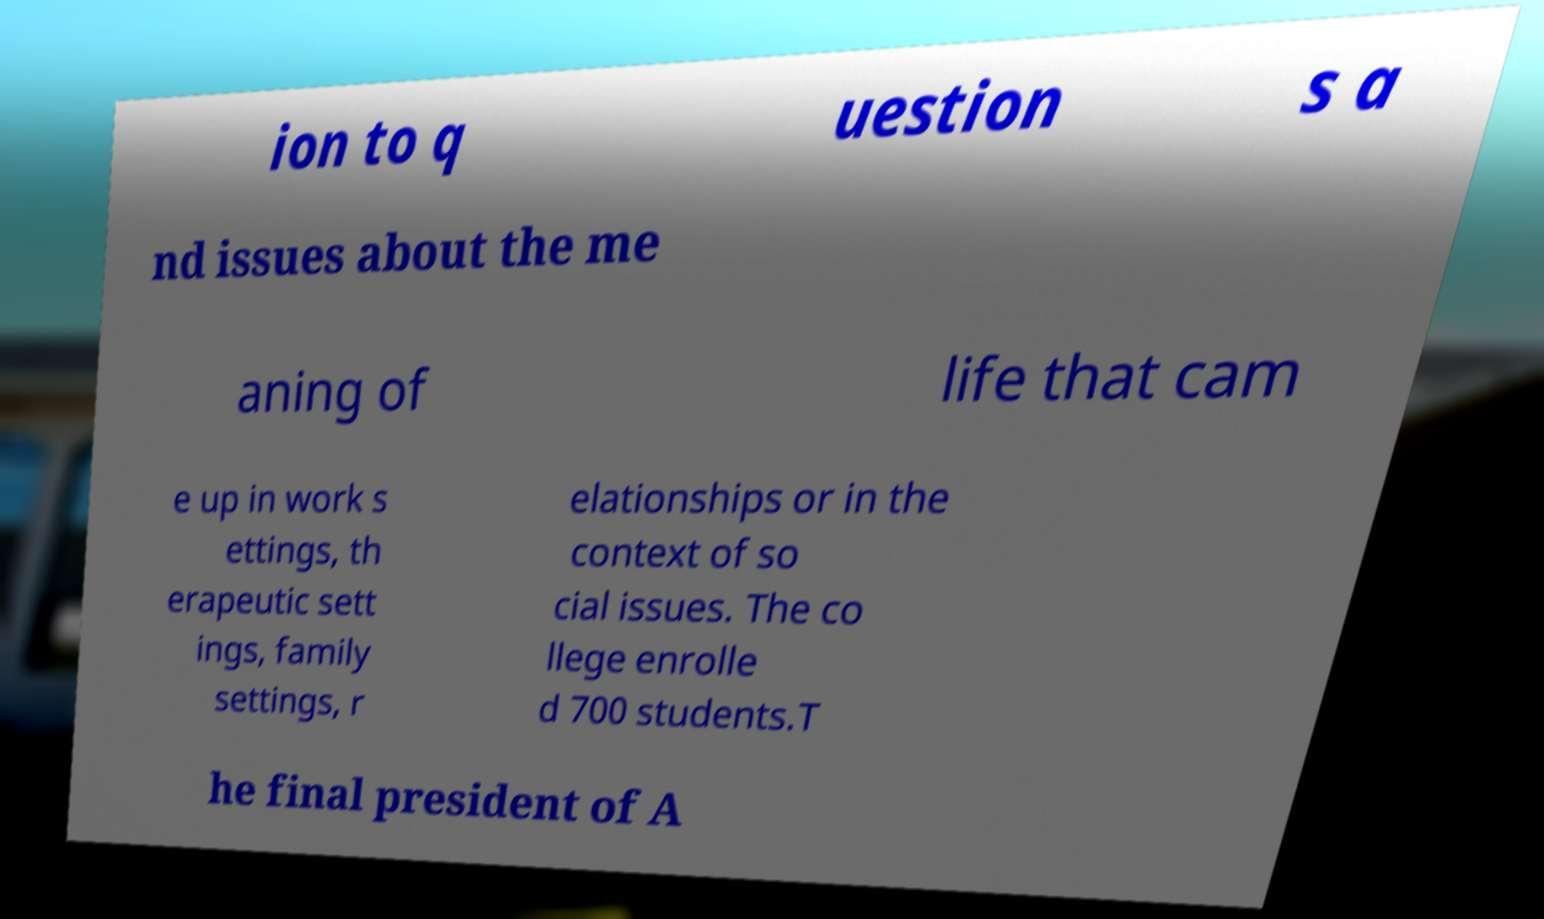There's text embedded in this image that I need extracted. Can you transcribe it verbatim? ion to q uestion s a nd issues about the me aning of life that cam e up in work s ettings, th erapeutic sett ings, family settings, r elationships or in the context of so cial issues. The co llege enrolle d 700 students.T he final president of A 